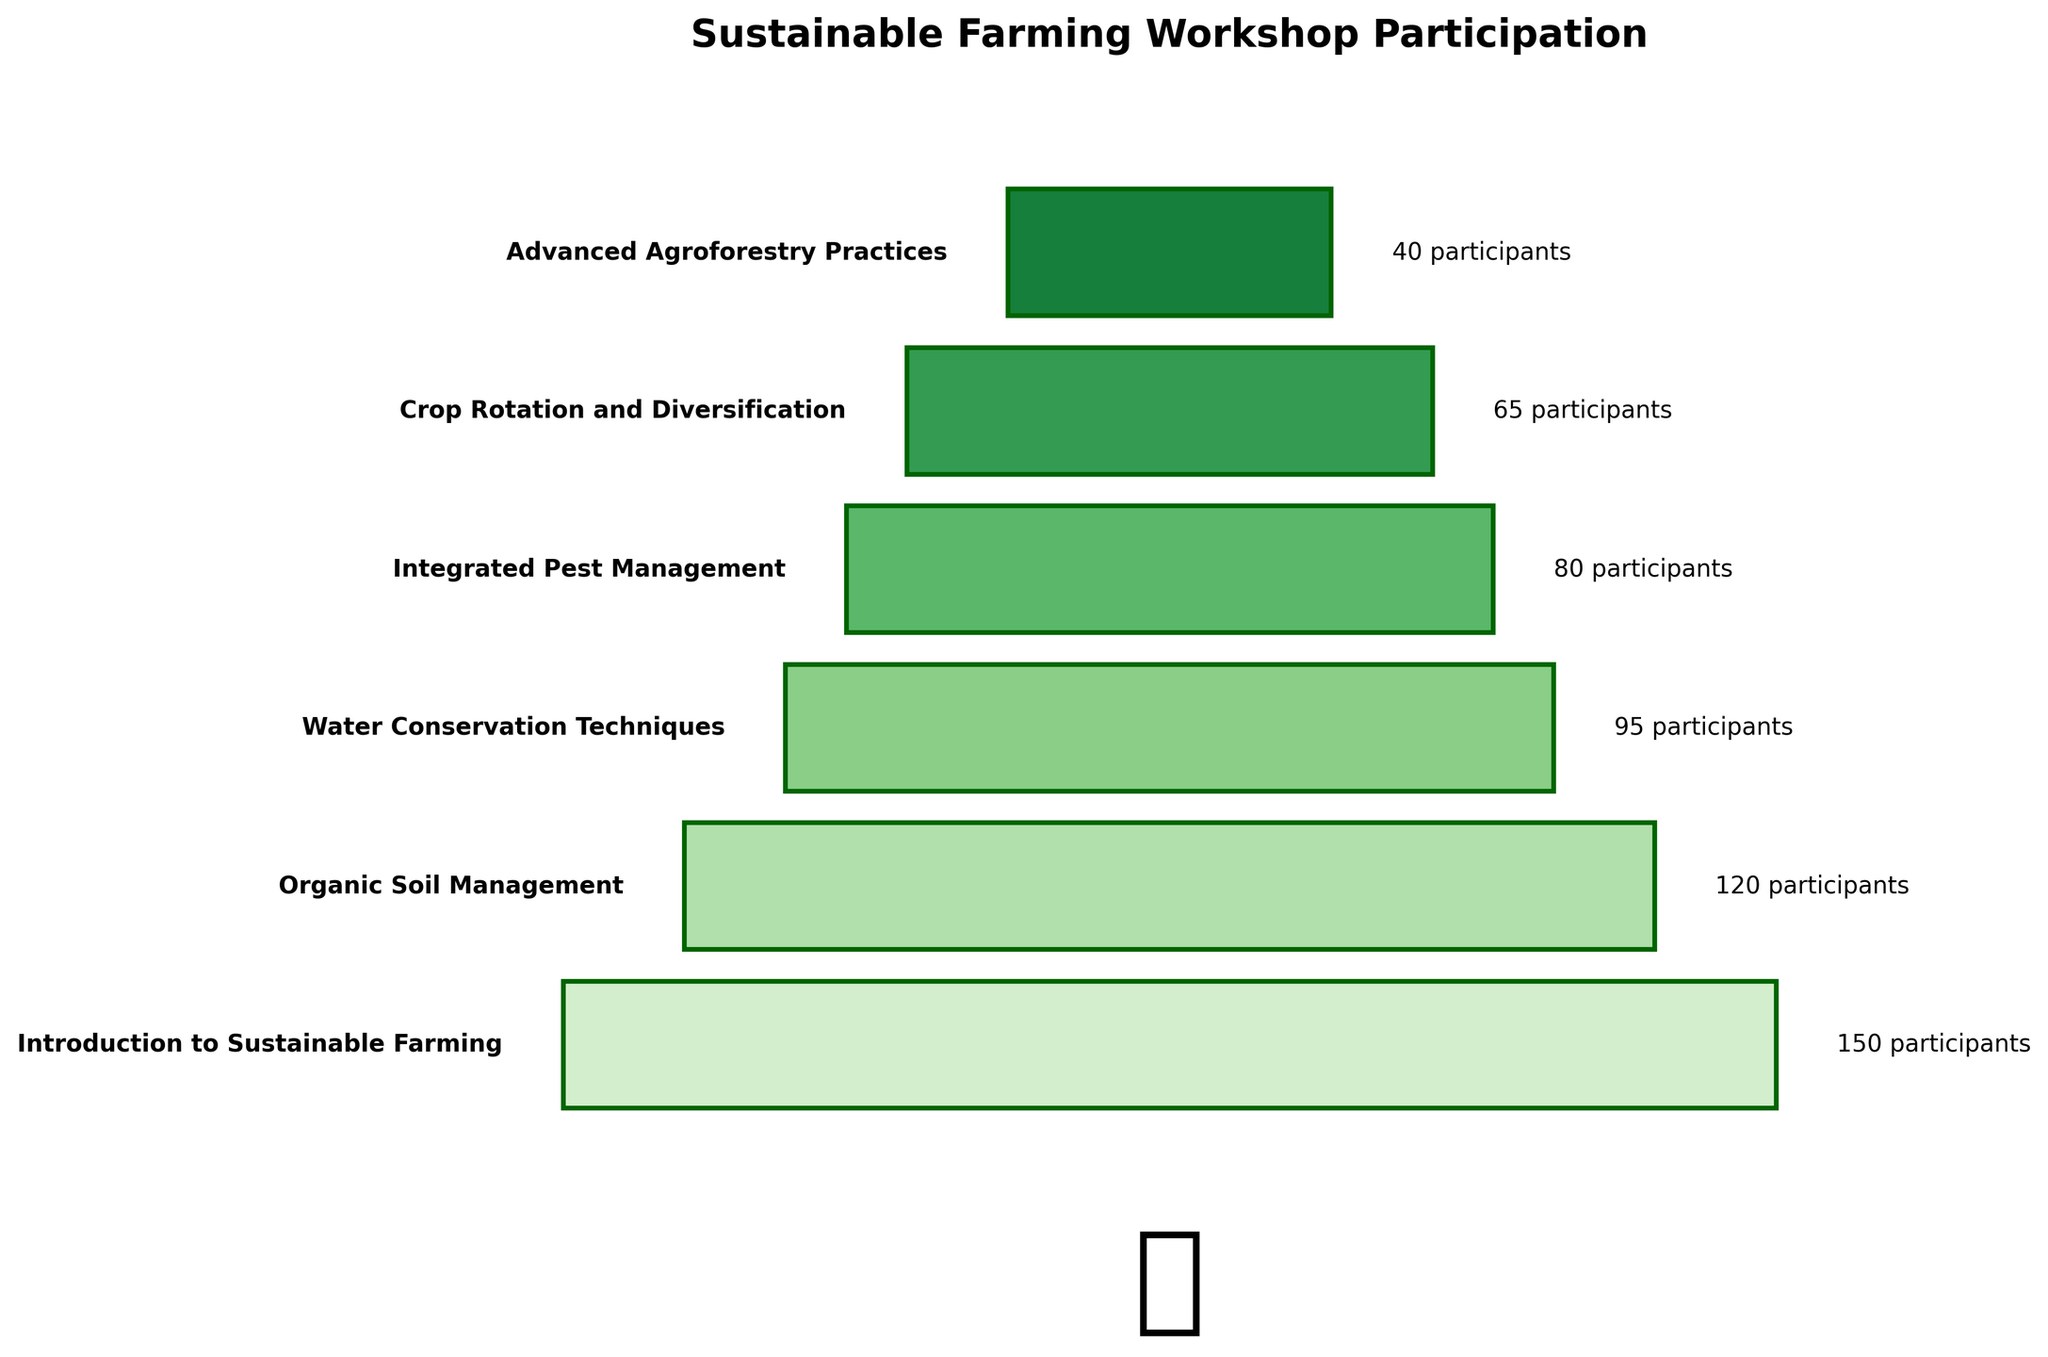What is the title of the funnel chart? The title of a chart is usually displayed prominently at the top of the figure. It summarizes the content of the chart in a concise manner.
Answer: Sustainable Farming Workshop Participation How many stages are represented in the funnel chart? The number of stages can be counted by looking at the names of different stages listed along the funnel.
Answer: 6 Which stage has the highest participation? By examining the width of the bars, the stage with the widest bar indicates the highest participation.
Answer: Introduction to Sustainable Farming What is the participation difference between 'Introduction to Sustainable Farming' and 'Integrated Pest Management'? To find the difference, subtract the number of participants in 'Integrated Pest Management' from 'Introduction to Sustainable Farming': 150 - 80.
Answer: 70 How many participants are in the stage 'Advanced Agroforestry Practices'? The number of participants is usually written next to the corresponding stage name on the funnel chart.
Answer: 40 On average, how many participants are there across all stages? To find the average, sum up the number of participants across all stages and divide by the number of stages: (150 + 120 + 95 + 80 + 65 + 40) / 6.
Answer: 91.67 Which stage has the least participation, and how many fewer participants does it have compared to 'Organic Soil Management'? Identify the stage with the narrowest bar, which indicates the least participation, and then calculate the difference from 'Organic Soil Management': 120 - 40.
Answer: Advanced Agroforestry Practices, 80 fewer participants What is the percentage drop in participation from the 'Introduction to Sustainable Farming' stage to the 'Water Conservation Techniques' stage? Calculate the difference and divide by the initial number, then multiply by 100 to convert to percentage: ((150 - 95) / 150) * 100.
Answer: 36.67% Are there more participants in 'Organic Soil Management' or 'Crop Rotation and Diversification'? Compare the number of participants in both stages directly from the chart.
Answer: Organic Soil Management How does the bar color intensity change from the 'Introduction to Sustainable Farming' stage to the 'Advanced Agroforestry Practices' stage? Observing the gradient in the color intensity across the stages, notice that the color gets lighter as the number of participants decreases.
Answer: The color intensity decreases 